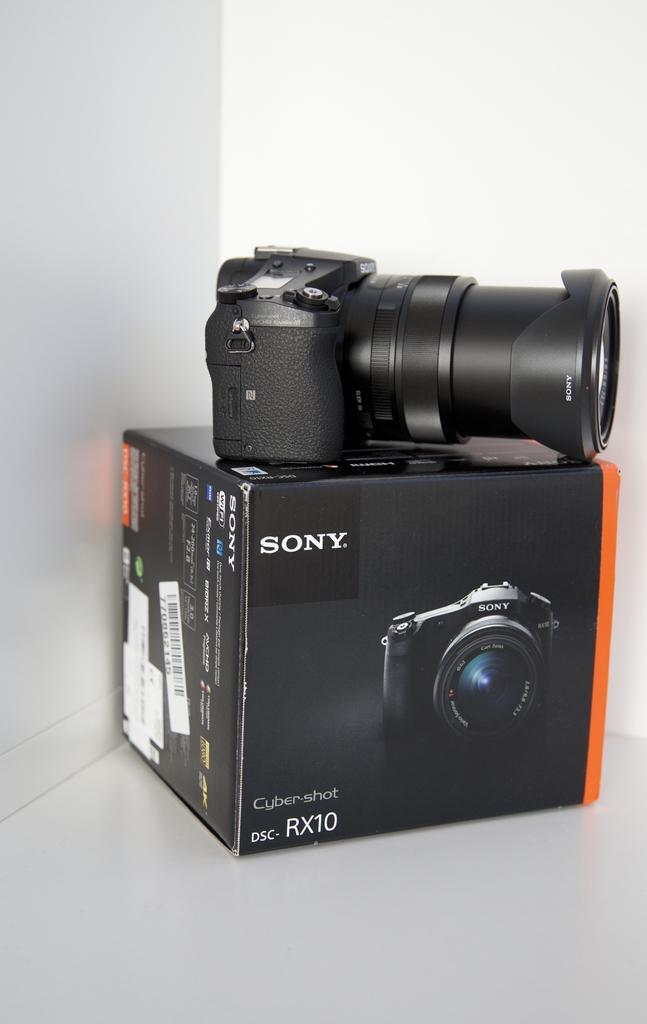Can you describe this image briefly? In this image there is a camera which is kept on the camera box. In the background there is a white color wall. 